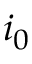Convert formula to latex. <formula><loc_0><loc_0><loc_500><loc_500>i _ { 0 }</formula> 